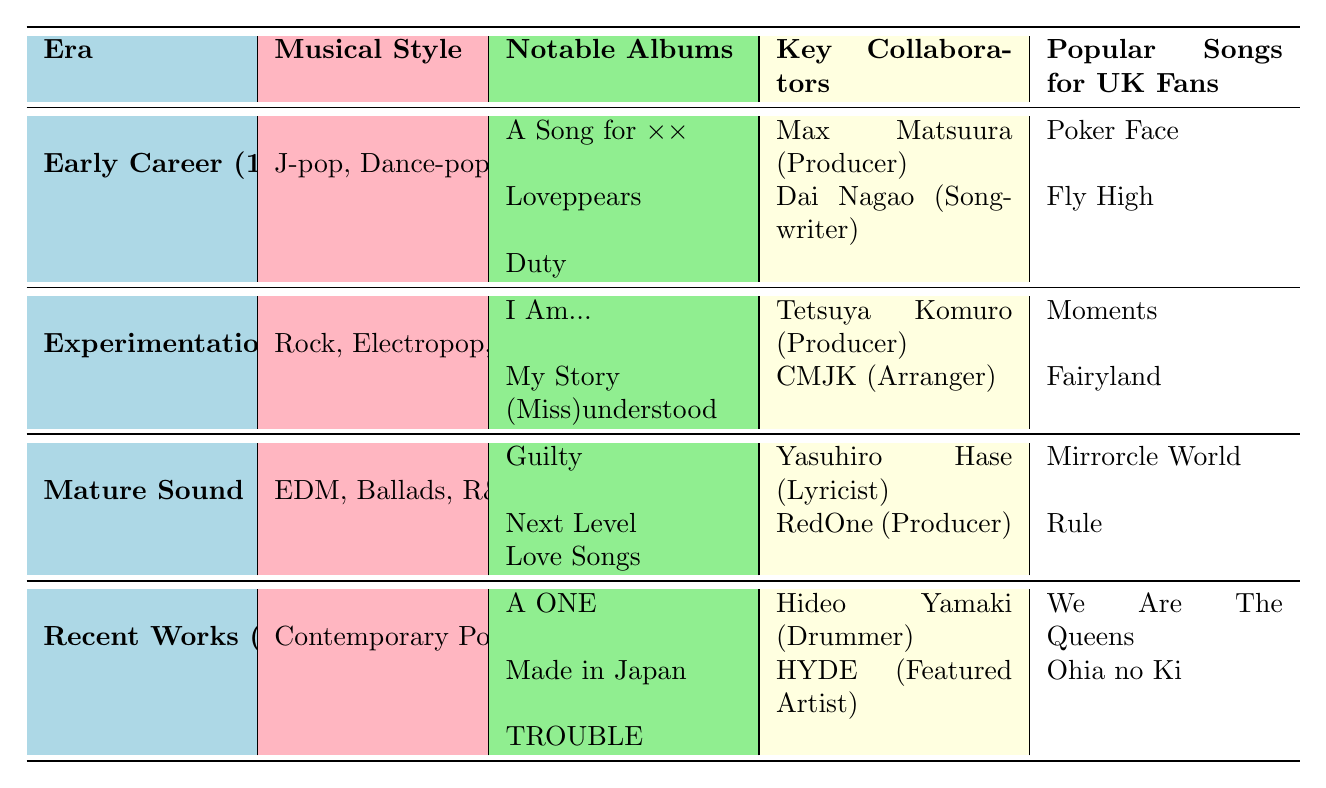What musical styles did Ayumi Hamasaki explore during her Early Career? According to the table, during her Early Career (1998-2002), Ayumi Hamasaki explored J-pop and Dance-pop as her musical styles.
Answer: J-pop, Dance-pop Which notable album was released in the Experimentation Phase? The table indicates that during the Experimentation Phase (2002-2007), notable albums included "I Am...", "My Story", and "(Miss)understood".
Answer: "I Am...", "My Story", "(Miss)understood" Who was the featured artist in Ayumi Hamasaki's Recent Works? Referring to the table, it shows that in her Recent Works (2015-present), HYDE was noted as a featured artist.
Answer: HYDE During which era did Ayumi collaborate with Tetsuya Komuro? The table specifies that Tetsuya Komuro was a collaborator during the Experimentation Phase (2002-2007).
Answer: Experimentation Phase (2002-2007) What are the popular songs associated with Ayumi Hamasaki's Mature Sound? The table reveals that popular songs for UK fans during the Mature Sound era (2008-2014) were "Mirrorcle World" and "Rule".
Answer: "Mirrorcle World", "Rule" Did Ayumi Hamasaki experiment with EDM during her Early Career? The data shows that during her Early Career (1998-2002), she focused on J-pop and Dance-pop, not EDM, so the statement is false.
Answer: No Which era has the most diverse musical styles based on the table? By analyzing the eras, the Experimentation Phase (2002-2007) includes Rock, Electropop, and Trance, demonstrating a diversity not exhibited in other eras that focus more on specific styles.
Answer: Experimentation Phase (2002-2007) How many key collaborators were listed for the Mature Sound era? The table lists two key collaborators for the Mature Sound era (2008-2014): Yasuhiro Hase (Lyricist) and RedOne (Producer).
Answer: 2 What is the sequence of musical styles Ayumi Hamasaki transitioned through from her Early Career to Recent Works? The table chronicles her journey from J-pop and Dance-pop, to Rock and Electropop with some Trance, followed by EDM and Ballads, finally leading to Contemporary Pop and Acoustic.
Answer: J-pop/Dance-pop → Rock/Electropop/Trance → EDM/Ballads/R&B → Contemporary Pop/Acoustic Among the popular songs, which two are from the Experimentation Phase? Referring to the table, the popular songs from the Experimentation Phase (2002-2007) are "Moments" and "Fairyland".
Answer: "Moments", "Fairyland" How does the variety of musical styles in the Recent Works compare to the Early Career? The Recent Works showcase a contemporary pop and acoustic style, which is a shift from the more defined J-pop and Dance-pop style of the Early Career, indicating a move toward more modern and varied musical expressions.
Answer: More varied in Recent Works 